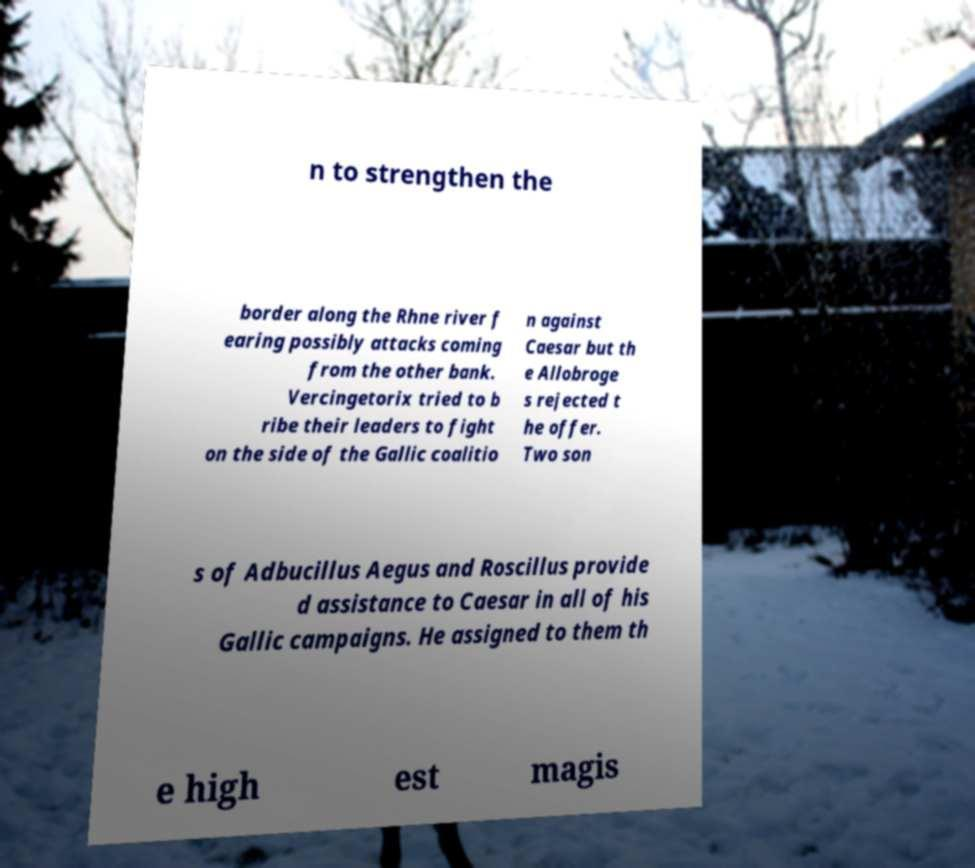Can you accurately transcribe the text from the provided image for me? n to strengthen the border along the Rhne river f earing possibly attacks coming from the other bank. Vercingetorix tried to b ribe their leaders to fight on the side of the Gallic coalitio n against Caesar but th e Allobroge s rejected t he offer. Two son s of Adbucillus Aegus and Roscillus provide d assistance to Caesar in all of his Gallic campaigns. He assigned to them th e high est magis 